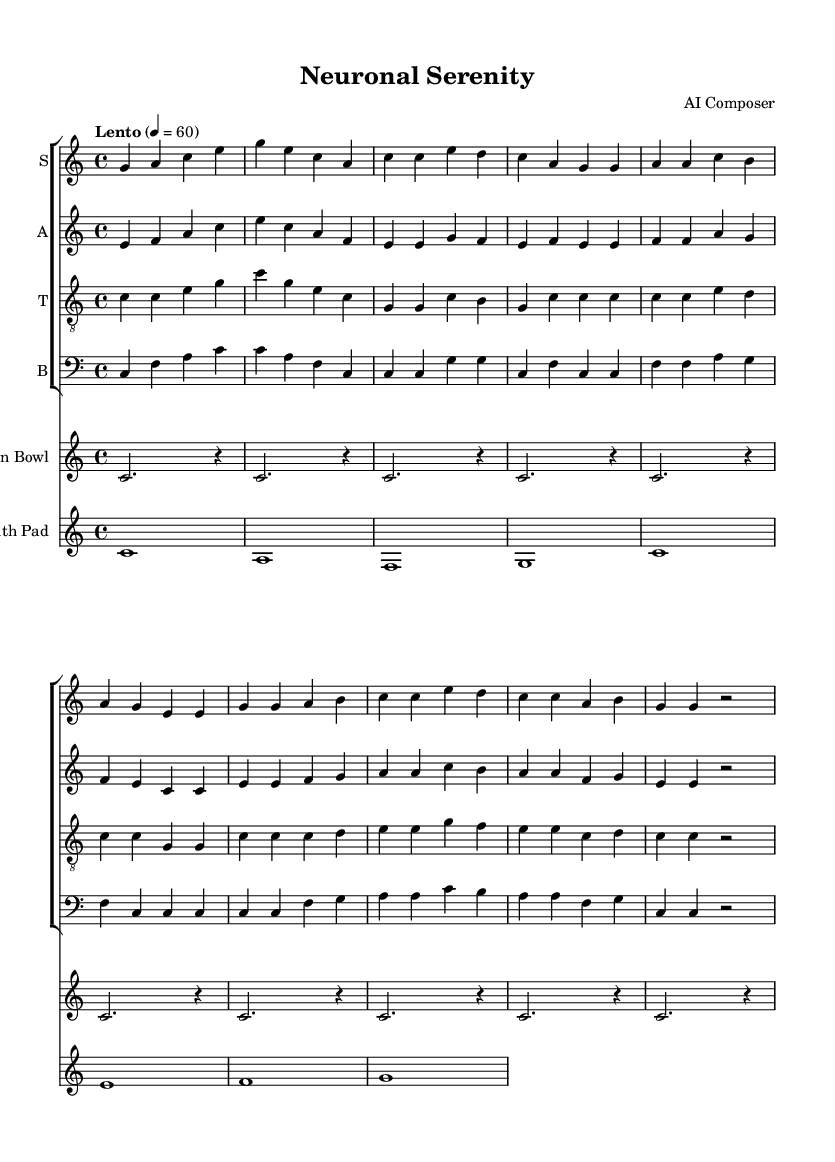What is the key signature of this music? The key signature is indicated by the absence of sharps or flats, which corresponds to C major.
Answer: C major What is the time signature of the piece? The time signature is shown at the beginning of the score, indicating a 4/4 meter, meaning there are four beats in each measure.
Answer: 4/4 What is the tempo marking for this composition? The tempo marking "Lento" appears above the staff, indicating a slow tempo, along with a metronome marking of 60 beats per minute.
Answer: Lento How many voices are present in this score? The score includes a total of four distinct vocal parts: soprano, alto, tenor, and bass, which can be verified by inspecting the labeled staves.
Answer: Four What chant is repeated in the verse? In the verse, the chant "Ohm... Ohm... Ohm... Ohm..." appears repetitively, underscoring its significance in meditative practices.
Answer: Ohm How does the musical texture change in the last four measures? In the last four measures, all voices converge on the note C while the other instrumental parts create a unifying sound, indicating a blend suitable for meditation.
Answer: Voices converge on C What do the lyrics suggest about the consciousness theme? The lyrics "Consciousness expands in the mind's quiet night" allude to themes of meditation, awareness, and the deepening of mental states, intrinsic to spiritual contemplation.
Answer: Expands in the mind's quiet night 